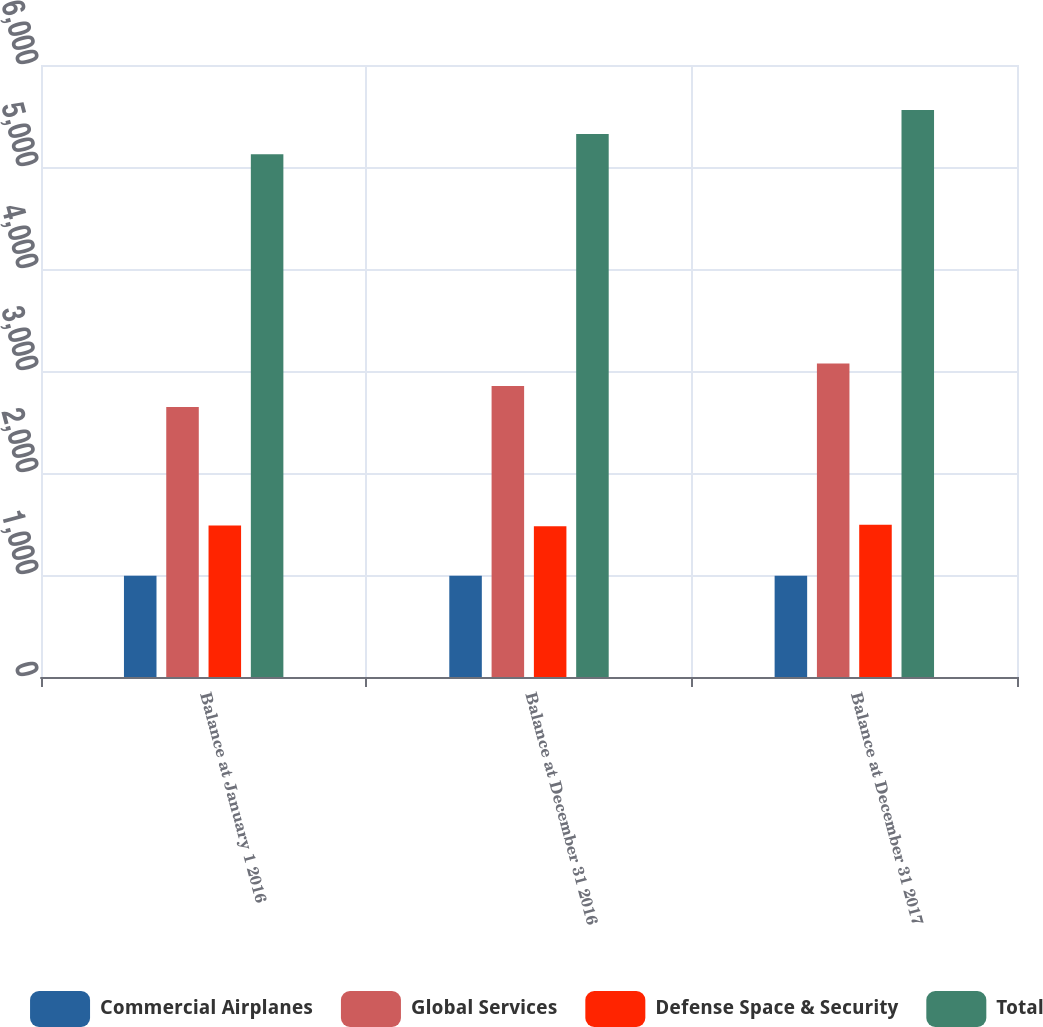Convert chart to OTSL. <chart><loc_0><loc_0><loc_500><loc_500><stacked_bar_chart><ecel><fcel>Balance at January 1 2016<fcel>Balance at December 31 2016<fcel>Balance at December 31 2017<nl><fcel>Commercial Airplanes<fcel>992<fcel>992<fcel>992<nl><fcel>Global Services<fcel>2648<fcel>2854<fcel>3074<nl><fcel>Defense Space & Security<fcel>1486<fcel>1478<fcel>1493<nl><fcel>Total<fcel>5126<fcel>5324<fcel>5559<nl></chart> 